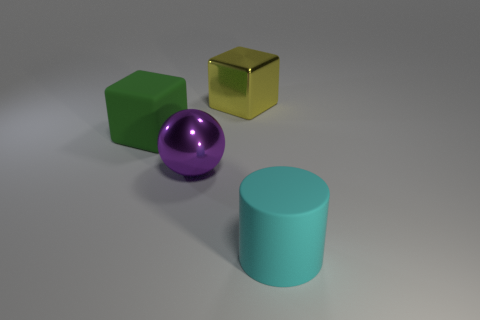Are there any large yellow objects in front of the big matte thing on the left side of the big yellow metallic cube?
Make the answer very short. No. What is the shape of the other large thing that is made of the same material as the large purple thing?
Your answer should be compact. Cube. Is there anything else that is the same color as the rubber cylinder?
Your response must be concise. No. What is the material of the green object that is the same shape as the yellow object?
Your answer should be very brief. Rubber. How many other things are there of the same size as the ball?
Provide a succinct answer. 3. There is a matte object to the left of the cyan rubber thing; is its shape the same as the big cyan object?
Ensure brevity in your answer.  No. How many other things are the same shape as the yellow object?
Offer a very short reply. 1. What is the shape of the matte object that is right of the big purple ball?
Keep it short and to the point. Cylinder. Are there any large brown things that have the same material as the cyan object?
Give a very brief answer. No. Is the color of the large rubber thing on the right side of the large matte block the same as the rubber block?
Offer a very short reply. No. 